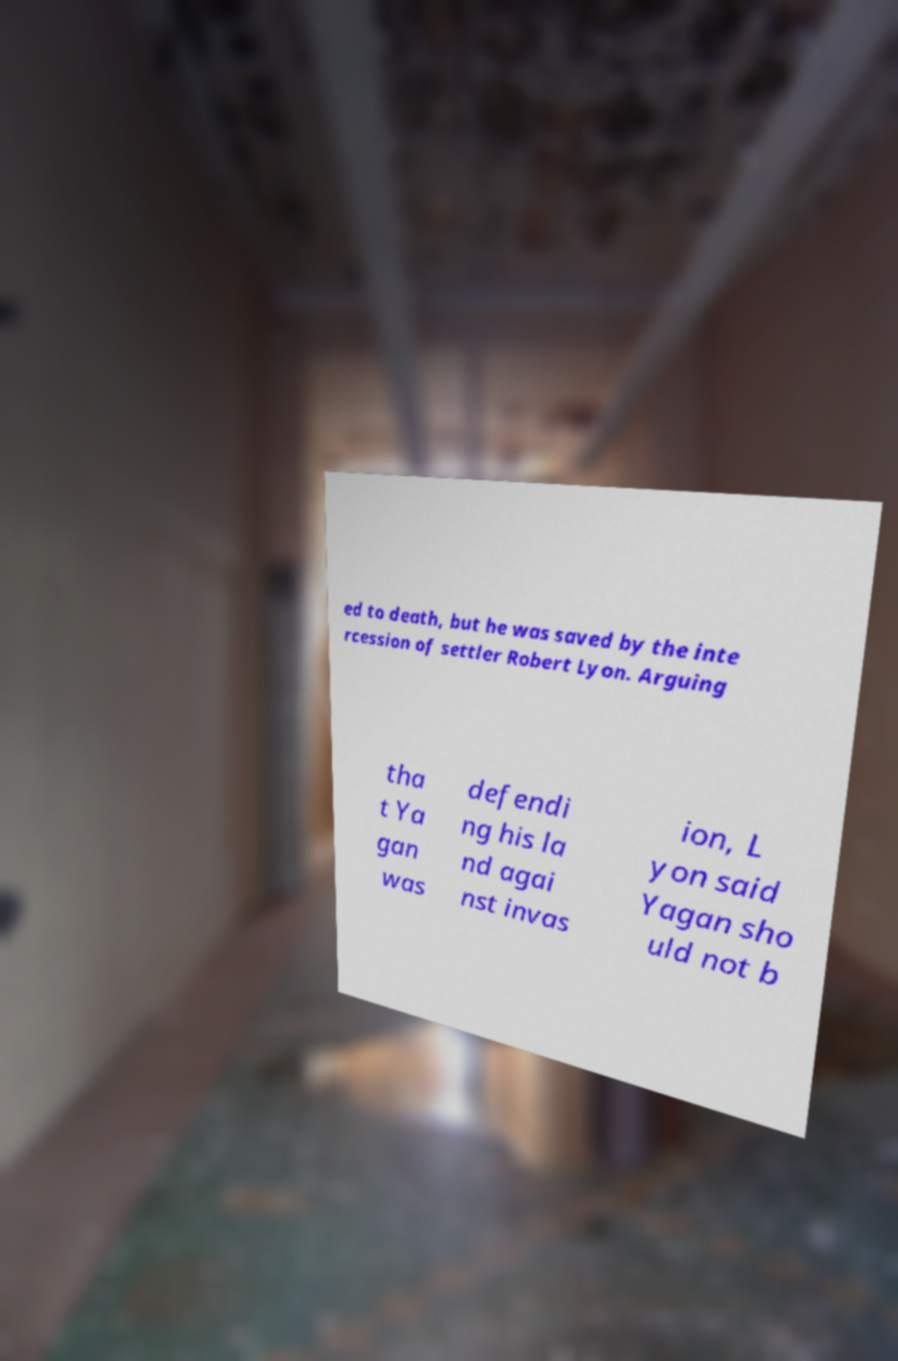For documentation purposes, I need the text within this image transcribed. Could you provide that? ed to death, but he was saved by the inte rcession of settler Robert Lyon. Arguing tha t Ya gan was defendi ng his la nd agai nst invas ion, L yon said Yagan sho uld not b 